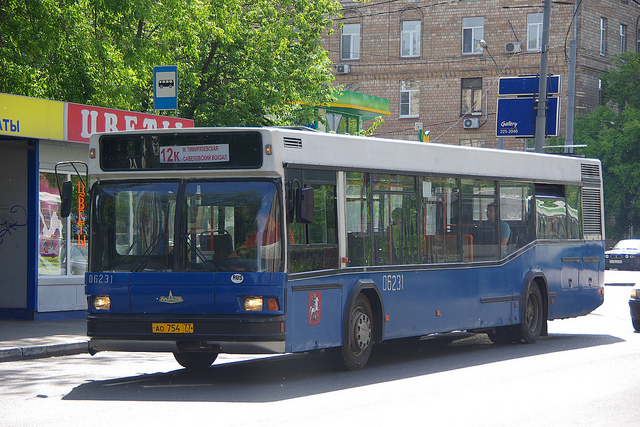<image>What is the buses maker? It is unknown who the maker of the bus is. It could possibly be Pace, Toyota, Nissan, Bluebird, or Ford. What is the buses maker? I don't know the maker of the bus. It can be 'pace', 'toyota', 'nissan', 'bluebird', or 'ford'. 